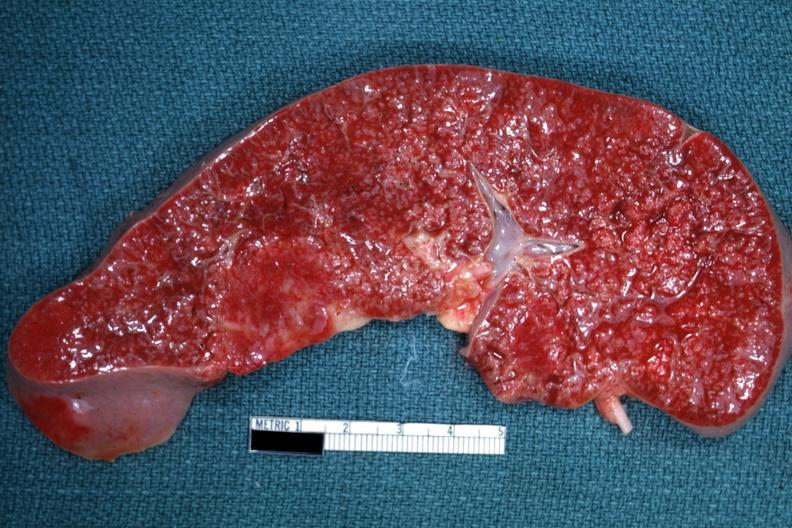what does this image show?
Answer the question using a single word or phrase. Cut surface with multiple small infiltrates that simulate granulomata diagnosed as reticulum cell sarcoma 